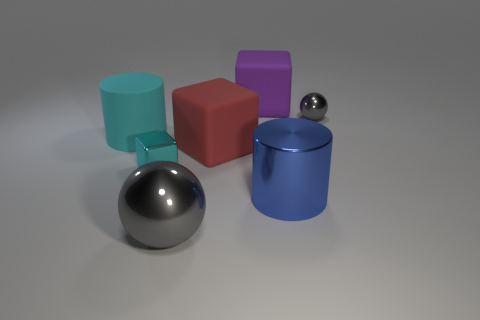What is the shape of the purple rubber object that is the same size as the red rubber thing?
Ensure brevity in your answer.  Cube. Do the cylinder on the left side of the tiny cyan metal thing and the small thing that is in front of the big red object have the same material?
Make the answer very short. No. How many big green shiny things are there?
Your response must be concise. 0. What number of large cyan metal objects have the same shape as the blue metallic object?
Offer a very short reply. 0. Is the shape of the red object the same as the small cyan shiny object?
Provide a succinct answer. Yes. The purple cube has what size?
Offer a very short reply. Large. How many cylinders have the same size as the red object?
Your answer should be compact. 2. Does the gray metallic object that is in front of the cyan rubber thing have the same size as the gray shiny sphere that is behind the large cyan object?
Ensure brevity in your answer.  No. What is the shape of the large purple rubber thing to the right of the red object?
Ensure brevity in your answer.  Cube. The gray object to the right of the gray thing that is on the left side of the blue metallic cylinder is made of what material?
Offer a very short reply. Metal. 